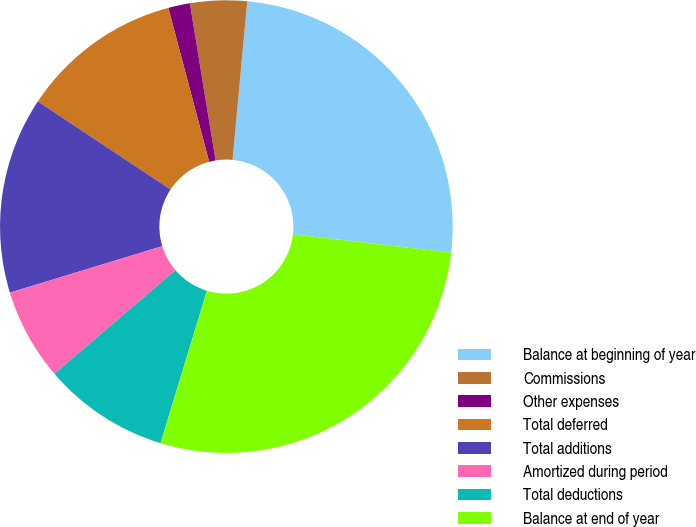<chart> <loc_0><loc_0><loc_500><loc_500><pie_chart><fcel>Balance at beginning of year<fcel>Commissions<fcel>Other expenses<fcel>Total deferred<fcel>Total additions<fcel>Amortized during period<fcel>Total deductions<fcel>Balance at end of year<nl><fcel>25.36%<fcel>4.05%<fcel>1.55%<fcel>11.54%<fcel>14.04%<fcel>6.55%<fcel>9.04%<fcel>27.86%<nl></chart> 